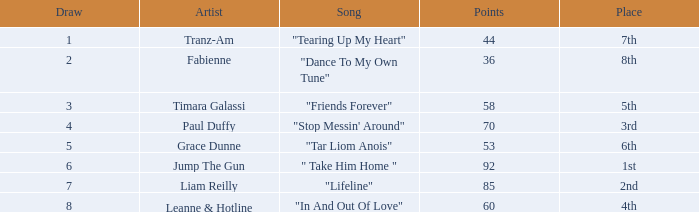What is the mean score for "in and out of love" when there is a draw with over 8 points? None. 